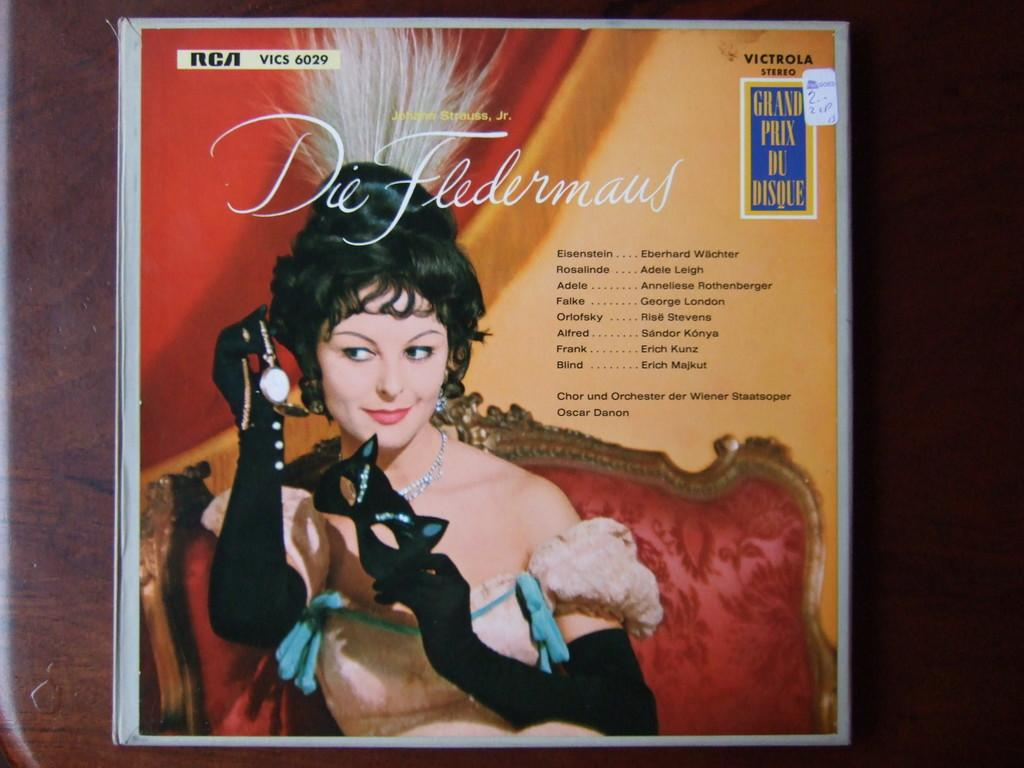What is present in the image? There is a poster in the image. Where is the poster located? The poster is on a surface. What is depicted on the poster? There is a woman sitting on a chair, and she is smiling. There is also a mask and a watch depicted on the poster. Are there any words on the poster? Yes, there is text on the poster. Can you hear the worm coughing in the image? There is no worm or coughing sound present in the image. 